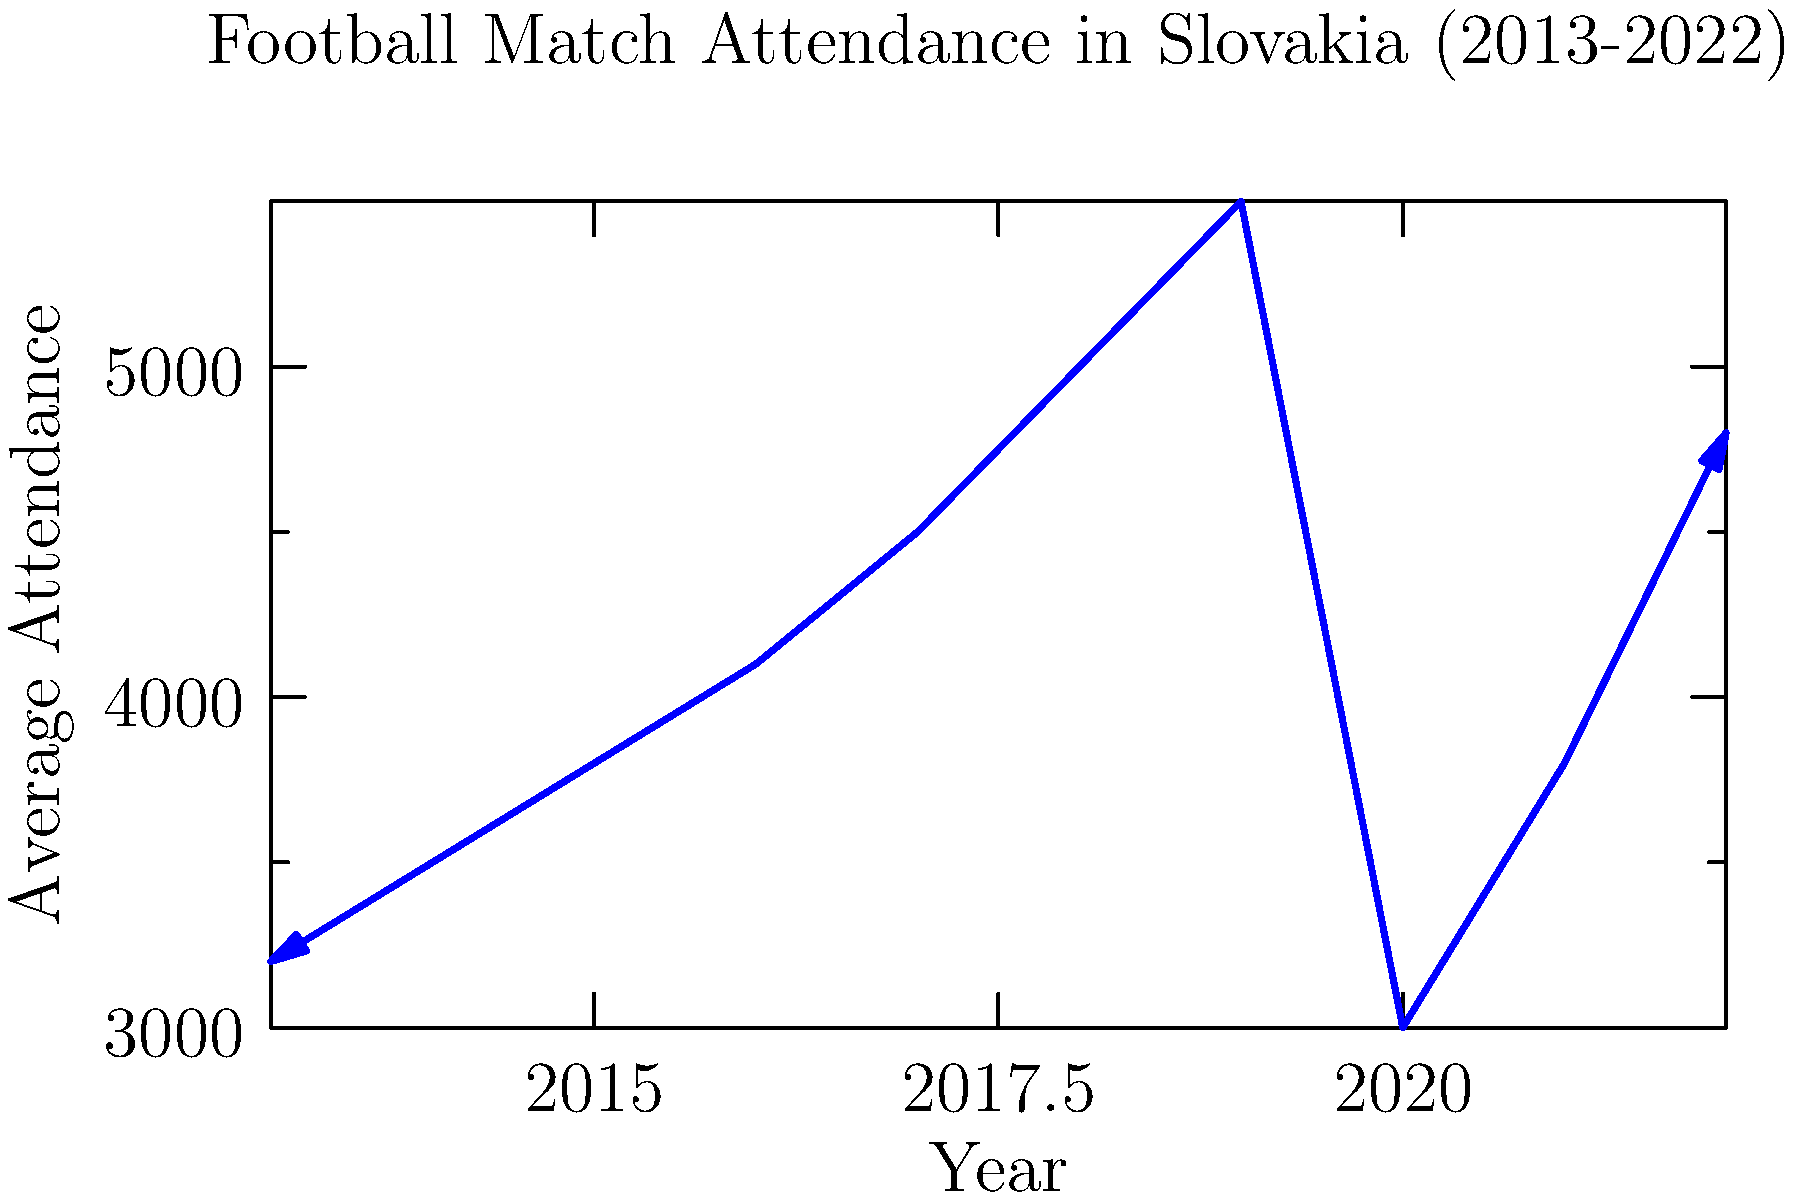Based on the line graph showing football match attendance trends in Slovakia over the past decade, which year saw the most significant drop in average attendance, and what could be a potential reason for this decline? To answer this question, we need to analyze the graph step-by-step:

1. Observe the overall trend: The graph shows a generally increasing trend from 2013 to 2019.

2. Identify the sharp decline: There's a significant drop in attendance between 2019 and 2020.

3. Quantify the decline: 
   - 2019 attendance: approximately 5500
   - 2020 attendance: approximately 3000
   - This represents a drop of about 2500 spectators.

4. Compare with other years: No other year-to-year change shows such a dramatic decrease.

5. Consider potential reasons: The year 2020 coincides with the global COVID-19 pandemic, which led to widespread restrictions on public gatherings, including sporting events.

6. Contextualize for Slovakia: As a sports reporter in Slovakia, you would be aware that many football matches in 2020 were played with limited or no spectators due to pandemic-related safety measures.

Therefore, 2020 saw the most significant drop in average attendance, likely due to COVID-19 restrictions.
Answer: 2020, due to COVID-19 pandemic restrictions. 